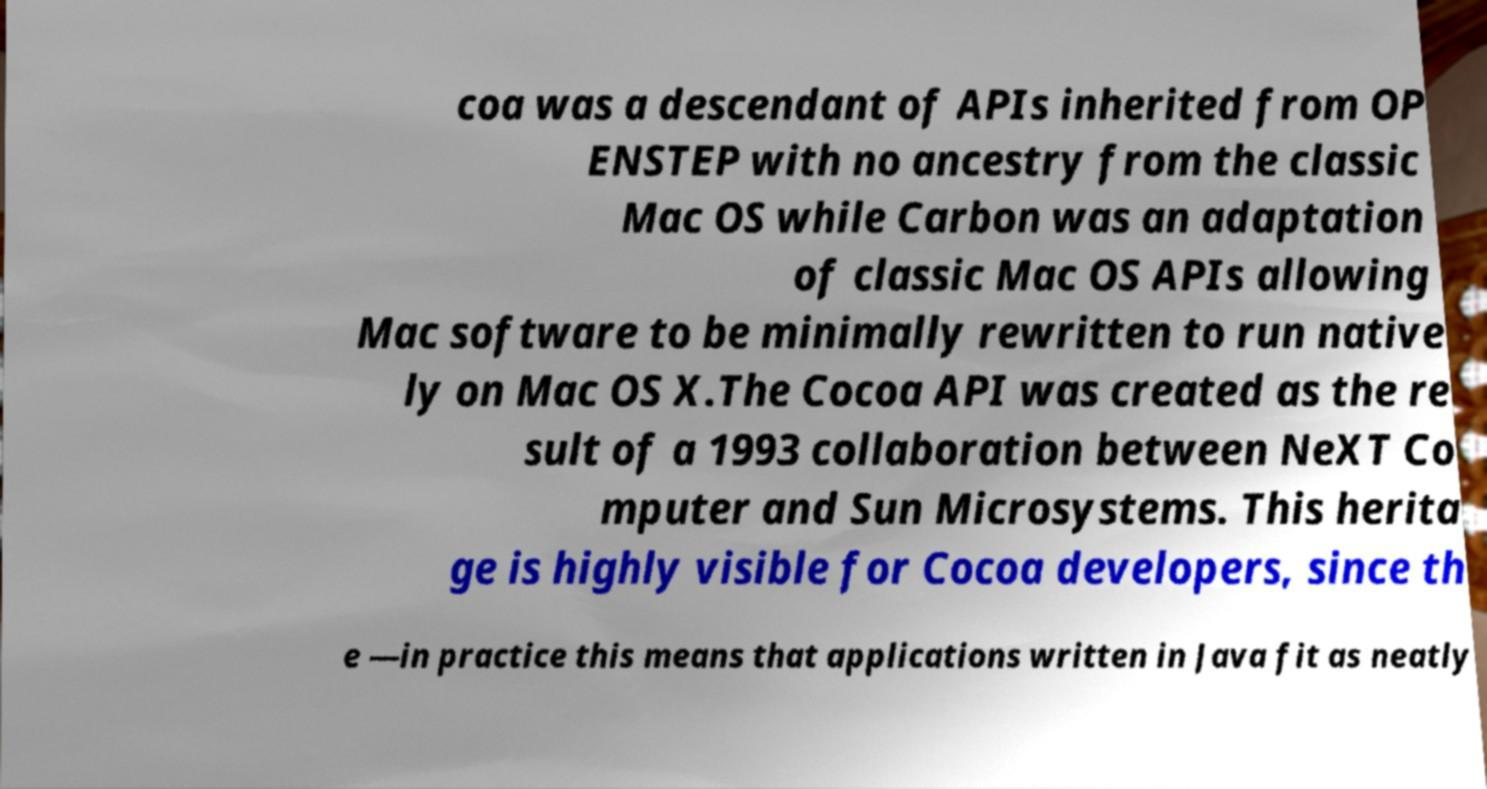What messages or text are displayed in this image? I need them in a readable, typed format. coa was a descendant of APIs inherited from OP ENSTEP with no ancestry from the classic Mac OS while Carbon was an adaptation of classic Mac OS APIs allowing Mac software to be minimally rewritten to run native ly on Mac OS X.The Cocoa API was created as the re sult of a 1993 collaboration between NeXT Co mputer and Sun Microsystems. This herita ge is highly visible for Cocoa developers, since th e —in practice this means that applications written in Java fit as neatly 